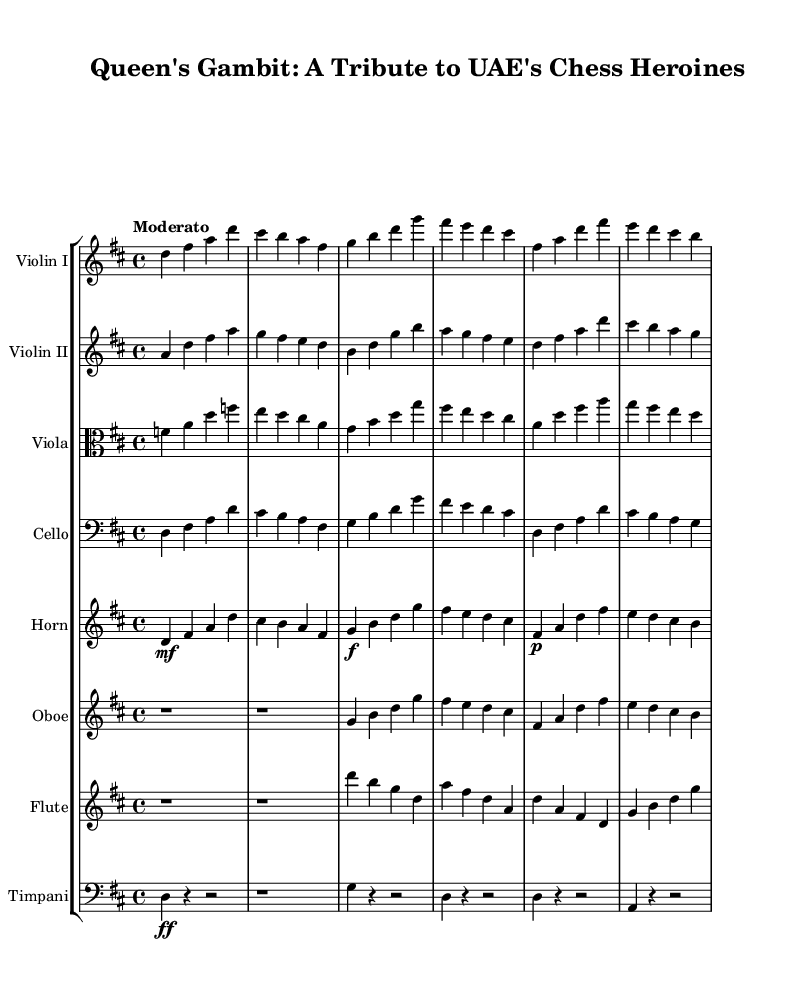What is the key signature of this music? The key signature is indicated by the number of sharps or flats at the beginning of the staff. Here, it shows two sharps (F♯ and C♯), which corresponds to D major.
Answer: D major What is the time signature of this music? The time signature is found at the beginning of the staff, specified as two numbers with the upper number indicating beats per measure and the lower indicating the note getting one beat. Here, it shows 4/4, meaning there are four beats in a measure and a quarter note gets one beat.
Answer: 4/4 What is the tempo marking for this piece? The tempo is indicated by the marking "Moderato," which suggests a moderate speed for performance.
Answer: Moderato How many different themes are presented in this composition? By analyzing the structure of the provided parts in the score, two distinct themes (Theme A and Theme B) are clearly defined in the composition.
Answer: 2 Which instrument has the melody in Theme A? Looking at the instrumental parts during Theme A, the Violin I prominent notes stand out. It carries the main melodic line when compared to the harmony in other instruments.
Answer: Violin I What dynamics are indicated for the horn in the introduction? The dynamics for the horn part in the introduction are marked as "mf" (mezzo-forte) followed by a "f" (forte) marking for the theme. This shows a progression in volume from moderately loud to loud.
Answer: mf and f What role does the timpani play in the composition? The timpani acts as a rhythmic foundation by providing accented beats and punctuating the themes, particularly throughout the introduction and the themes by playing quarter notes.
Answer: Rhythmic foundation 